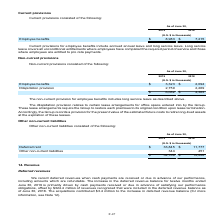According to Atlassian Plc's financial document, What does the dilapidation provision relate to? Certain lease arrangements for office space entered into by the Group. The document states: "The dilapidation provision relates to certain lease arrangements for office space entered into by the Group...." Also, What is the total non-current provisions for fiscal years 2018 and 2019 respectively? The document shows two values: $4,363 and $6,082 (in thousands). From the document: "$ 6,082 $ 4,363 $ 6,082 $ 4,363..." Also, What is the dilapidation provision for fiscal year 2019? According to the financial document, 2,759 (in thousands). The relevant text states: "Dilapidation provision 2,759 2,269..." Also, can you calculate: What is the average employee benefits for fiscal years 2018 and 2019? To answer this question, I need to perform calculations using the financial data. The calculation is: (3,323+2,094)/2, which equals 2708.5 (in thousands). This is based on the information: "Employee benefits $ 3,323 $ 2,094 Employee benefits $ 3,323 $ 2,094..." The key data points involved are: 2,094, 3,323. Also, can you calculate: What is the difference in the total non-current provision between fiscal years 2018 and 2019? Based on the calculation: 6,082-4,363, the result is 1719 (in thousands). This is based on the information: "$ 6,082 $ 4,363 $ 6,082 $ 4,363..." The key data points involved are: 4,363, 6,082. Also, can you calculate: In fiscal year 2019, what is the percentage constitution of employee benefits among the total non-current provisions? Based on the calculation: 3,323/6,082, the result is 54.64 (percentage). This is based on the information: "$ 6,082 $ 4,363 Employee benefits $ 3,323 $ 2,094..." The key data points involved are: 3,323, 6,082. 